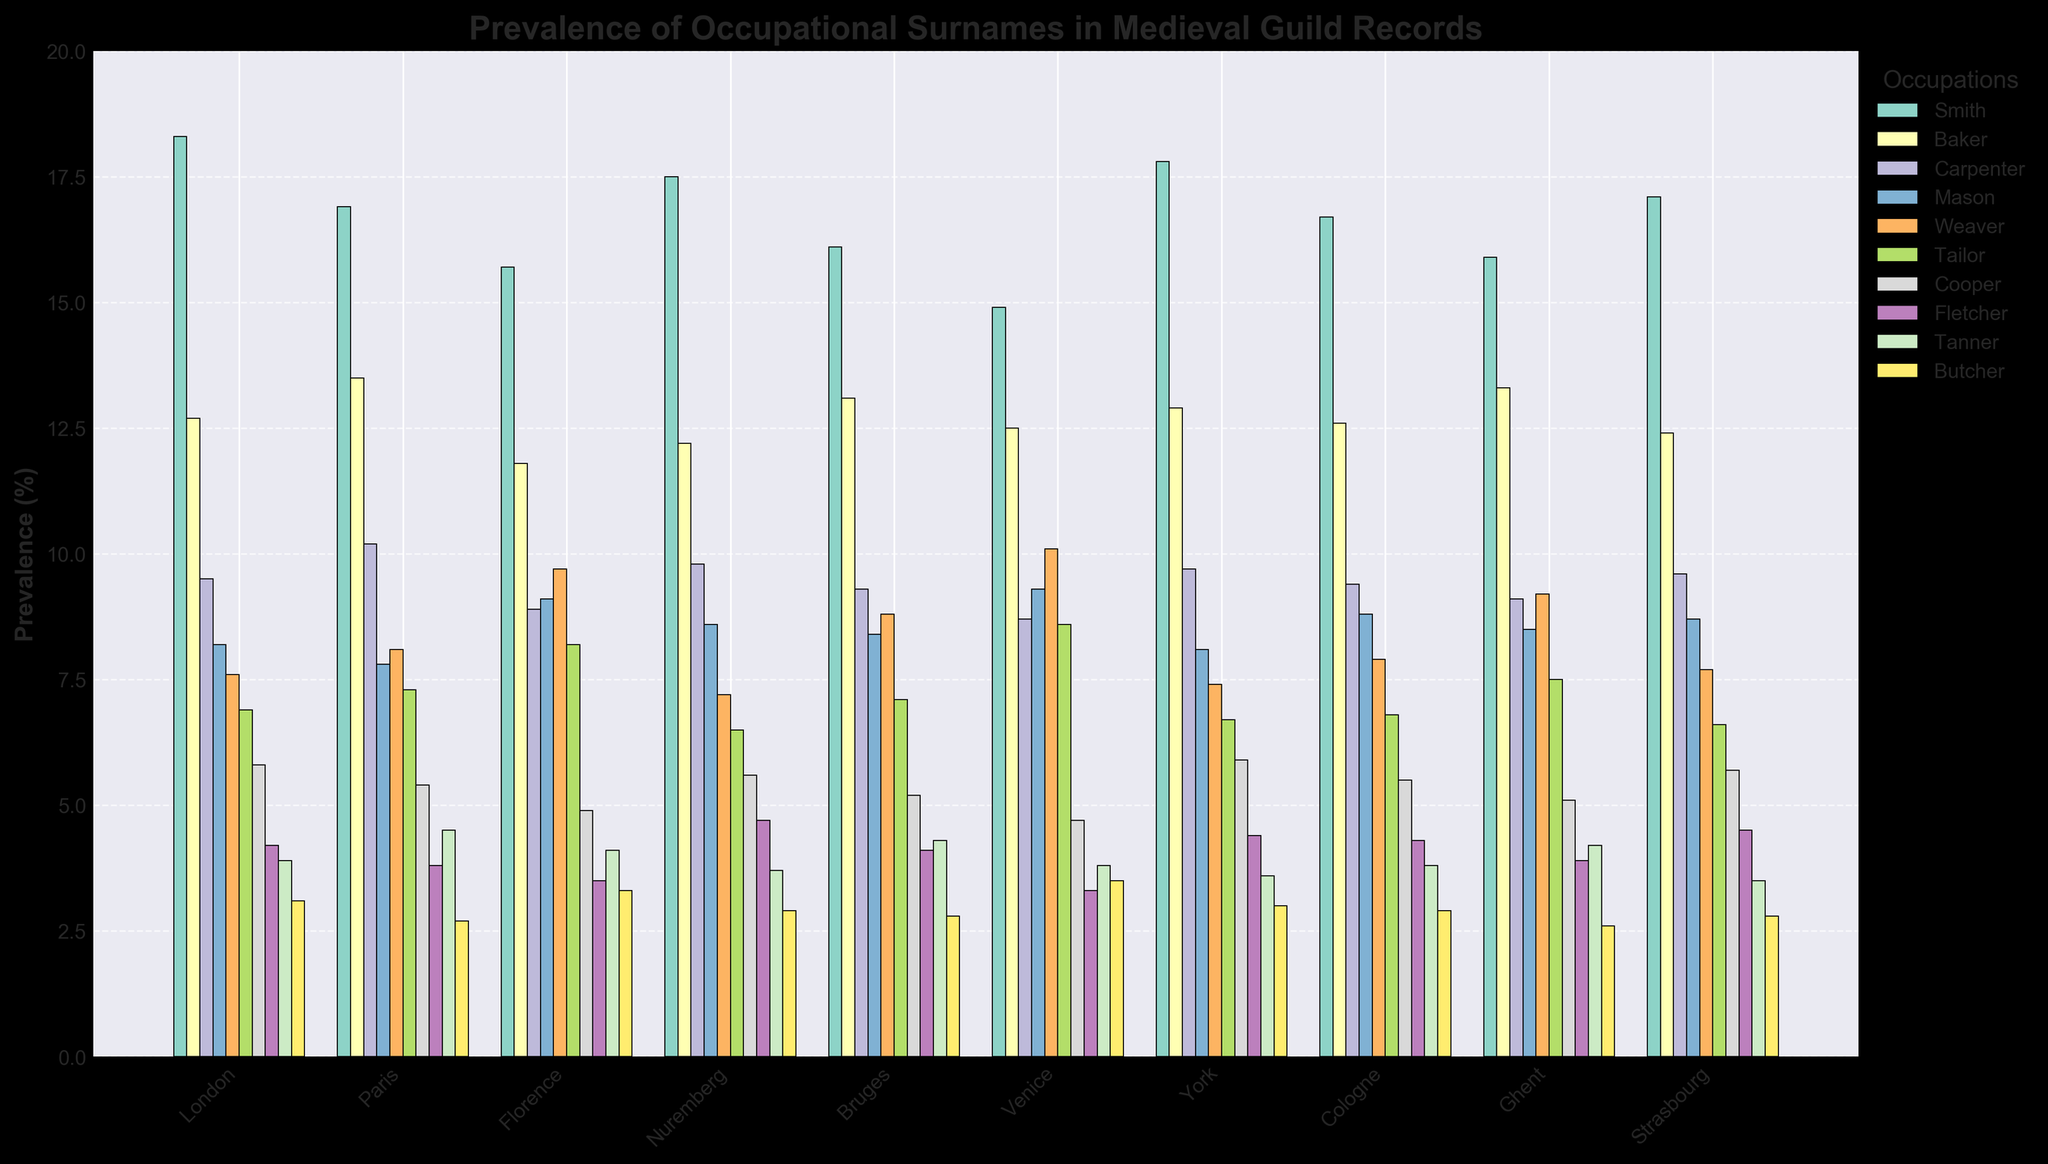Which city has the highest prevalence of the surname "Smith"? To determine which city has the highest prevalence of the surname "Smith", look for the tallest bar among those representing "Smith" across all cities. The bar for London (18.3%) is the highest.
Answer: London Between Paris and Florence, which city has a higher percentage of the surname "Tailor"? Compare the height of the "Tailor" bars for Paris (7.3%) and Florence (8.2%). Florence has a taller bar, indicating a higher percentage.
Answer: Florence Summing up the percentage prevalence for "Baker" in York, Cologne, and Ghent, what is the total? Add the percentages for "Baker" in York (12.9%), Cologne (12.6%), and Ghent (13.3%): 12.9% + 12.6% + 13.3% = 38.8%.
Answer: 38.8% Which city has the lowest prevalence for the surname "Butcher"? Look for the shortest bar among those representing "Butcher" across all cities. The shortest bar represents Ghent (2.6%).
Answer: Ghent Is the prevalence of "Weaver" higher in Venice or Florence? Compare the height of the "Weaver" bars for Venice (10.1%) and Florence (9.7%). Venice has a taller bar, indicating a higher percentage.
Answer: Venice What is the average prevalence of the surname "Carpenter" across all cities? Sum the percentage values for "Carpenter" across all cities and divide by the number of cities: (9.5 + 10.2 + 8.9 + 9.8 + 9.3 + 8.7 + 9.7 + 9.4 + 9.1 + 9.6) / 10 = 9.42%.
Answer: 9.42% Which occupation has the most consistent prevalence across all cities? By visually assessing the variation in bar heights for each occupation across all cities, the surname "Cooper" shows the most consistent height, indicating the smallest variance.
Answer: Cooper Comparing London and Nuremberg, which city has a higher combined prevalence of "Smith" and "Baker" surnames? Add the percentages for "Smith" and "Baker" in London (18.3% + 12.7% = 31.0%) and in Nuremberg (17.5% + 12.2% = 29.7%). London has a higher combined prevalence.
Answer: London What's the difference in the prevalence of the surname "Mason" between Cologne and Bruges? Subtract the percentage for "Mason" in Bruges (8.4%) from Cologne (8.8%): 8.8% - 8.4% = 0.4%.
Answer: 0.4% Which two occupations have the least difference in prevalence in Paris? Compare the bars for each occupation in Paris and find the two with the closest height. "Smith" (16.9%) and "Weaver" (8.1%) have a difference of 8.8%, while "Butcher" (2.7%) and "Cooper" (5.4%) have the closest difference of 2.7%.
Answer: Butcher and Cooper 